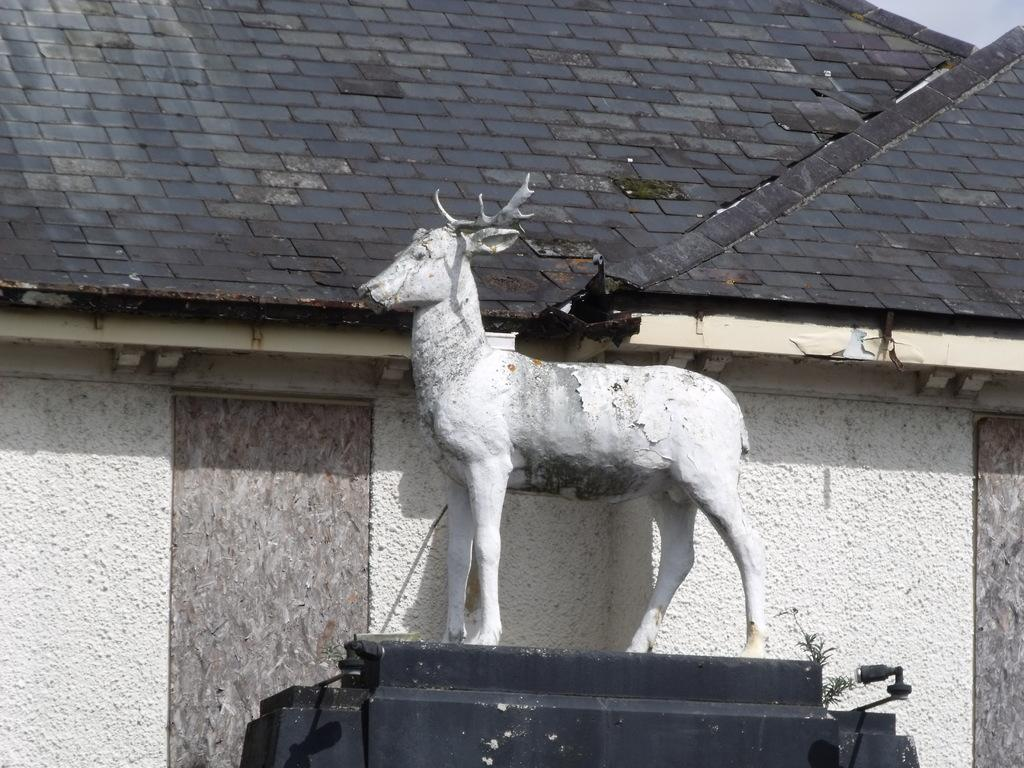What is the main subject in the center of the image? There is a sculpture in the center of the image. What can be seen in the background of the image? There are sheds in the background of the image. What type of snow is falling on the sculpture in the image? There is no snow present in the image; it is not mentioned in the provided facts. 